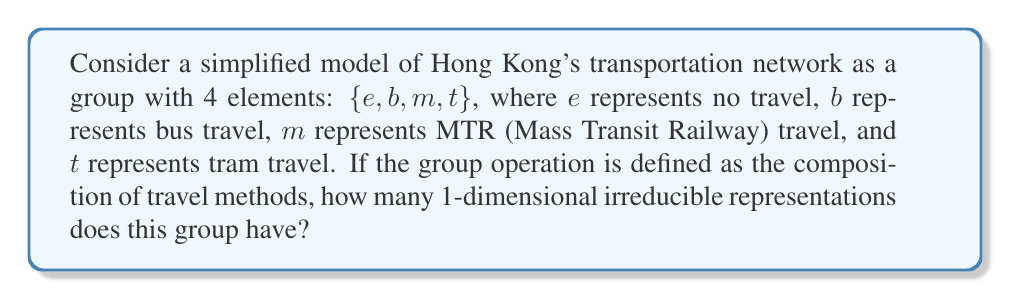Can you solve this math problem? To solve this problem, we'll follow these steps:

1) First, we need to understand what the group structure represents. In this case, it's a simplified model of Hong Kong's transportation network.

2) The group has 4 elements: {e, b, m, t}. For a geographic enthusiast unfamiliar with Hong Kong, we can think of these as different modes of getting around the city.

3) In representation theory, the number of 1-dimensional irreducible representations of a group is equal to the number of conjugacy classes in the group.

4) To find the conjugacy classes, we need to determine if this group is abelian (commutative). In an abelian group, each element forms its own conjugacy class.

5) For this transportation network, we can assume that the order of travel doesn't matter (e.g., taking a bus and then the MTR is equivalent to taking the MTR and then a bus). This means the group is abelian.

6) Since the group is abelian and has 4 elements, there are 4 conjugacy classes, each containing one element.

7) Therefore, the number of 1-dimensional irreducible representations is equal to the number of conjugacy classes, which is 4.

This result tells us that there are 4 distinct ways to represent this simplified transportation network in terms of 1-dimensional vector spaces.
Answer: 4 